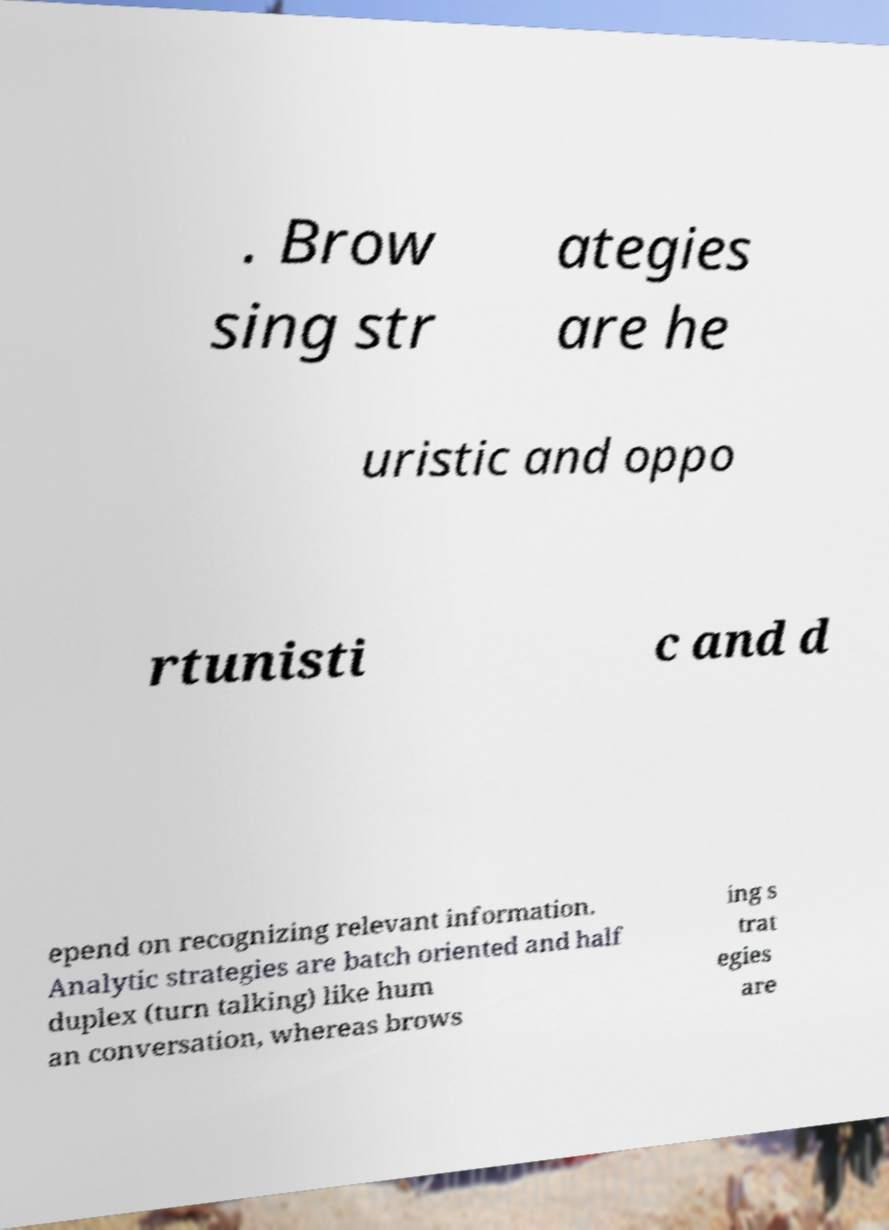Please read and relay the text visible in this image. What does it say? . Brow sing str ategies are he uristic and oppo rtunisti c and d epend on recognizing relevant information. Analytic strategies are batch oriented and half duplex (turn talking) like hum an conversation, whereas brows ing s trat egies are 